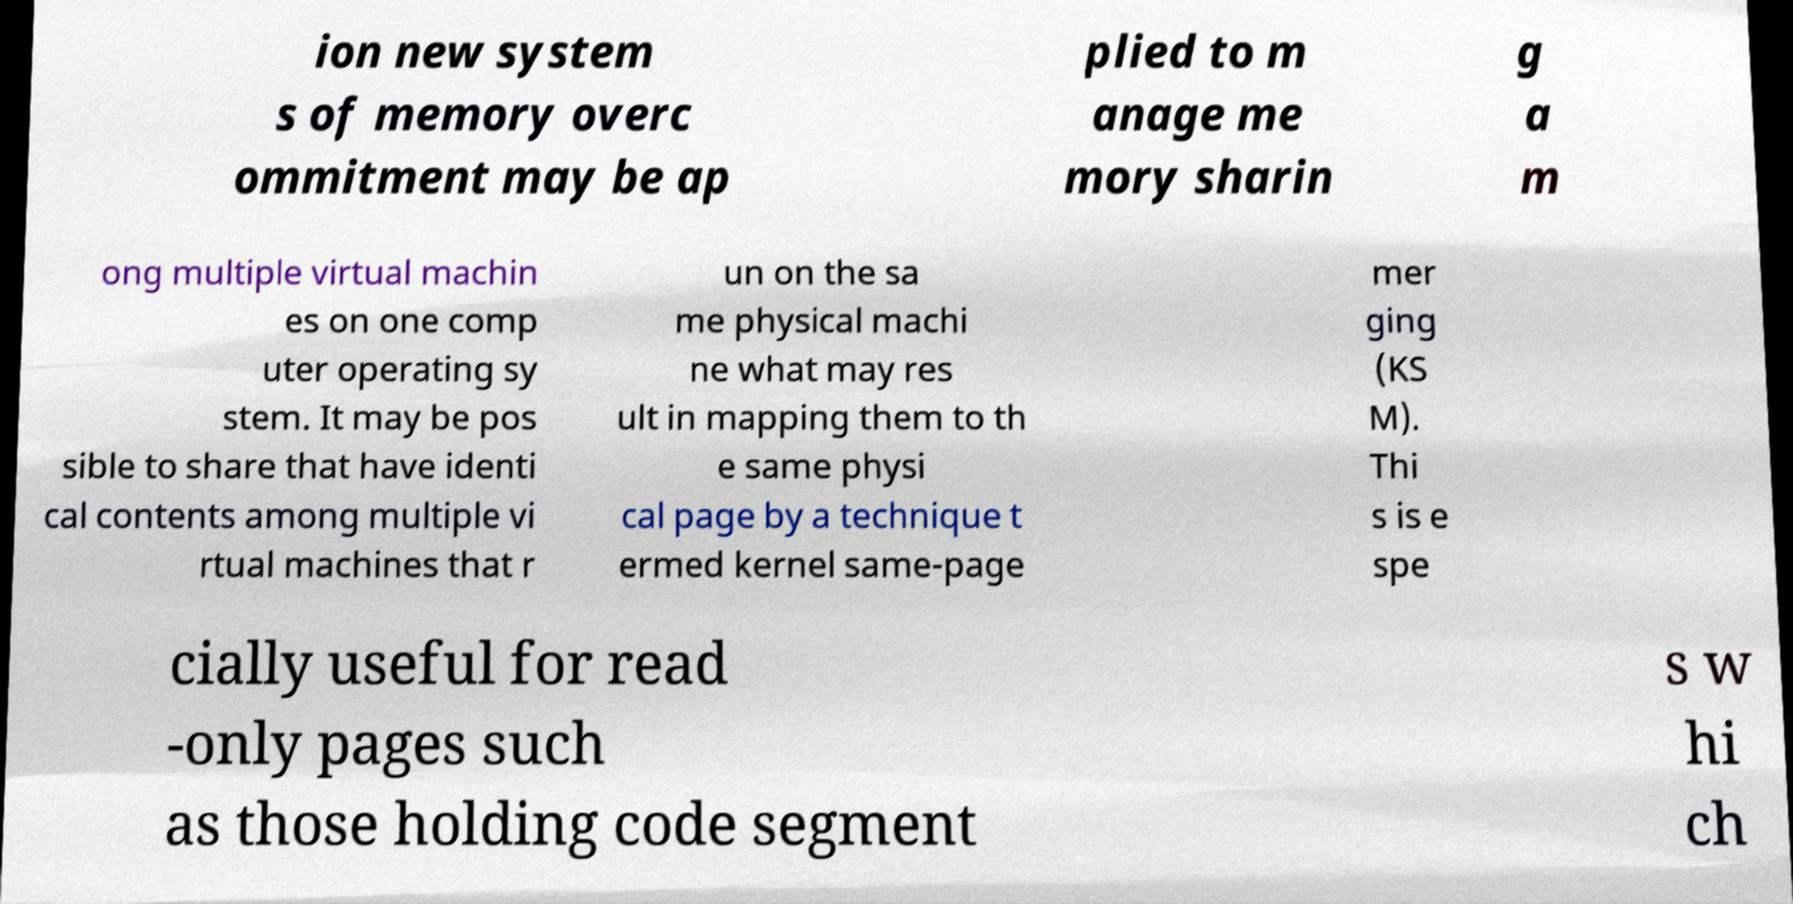For documentation purposes, I need the text within this image transcribed. Could you provide that? ion new system s of memory overc ommitment may be ap plied to m anage me mory sharin g a m ong multiple virtual machin es on one comp uter operating sy stem. It may be pos sible to share that have identi cal contents among multiple vi rtual machines that r un on the sa me physical machi ne what may res ult in mapping them to th e same physi cal page by a technique t ermed kernel same-page mer ging (KS M). Thi s is e spe cially useful for read -only pages such as those holding code segment s w hi ch 